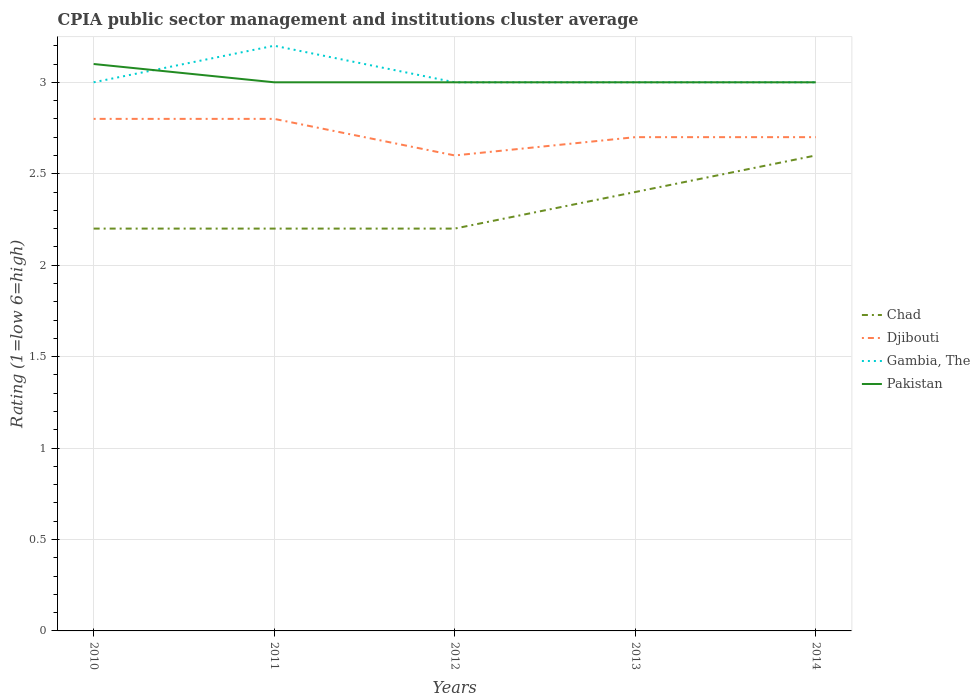Is the number of lines equal to the number of legend labels?
Make the answer very short. Yes. Across all years, what is the maximum CPIA rating in Chad?
Your answer should be very brief. 2.2. What is the difference between the highest and the second highest CPIA rating in Gambia, The?
Offer a terse response. 0.2. What is the difference between the highest and the lowest CPIA rating in Djibouti?
Your answer should be compact. 2. How many years are there in the graph?
Provide a short and direct response. 5. Are the values on the major ticks of Y-axis written in scientific E-notation?
Your response must be concise. No. Does the graph contain grids?
Your answer should be very brief. Yes. How many legend labels are there?
Give a very brief answer. 4. How are the legend labels stacked?
Offer a very short reply. Vertical. What is the title of the graph?
Offer a very short reply. CPIA public sector management and institutions cluster average. What is the label or title of the X-axis?
Provide a short and direct response. Years. What is the Rating (1=low 6=high) of Djibouti in 2010?
Provide a short and direct response. 2.8. What is the Rating (1=low 6=high) of Gambia, The in 2010?
Offer a very short reply. 3. What is the Rating (1=low 6=high) of Chad in 2011?
Offer a terse response. 2.2. What is the Rating (1=low 6=high) of Djibouti in 2011?
Make the answer very short. 2.8. What is the Rating (1=low 6=high) of Gambia, The in 2011?
Offer a terse response. 3.2. What is the Rating (1=low 6=high) of Pakistan in 2011?
Give a very brief answer. 3. What is the Rating (1=low 6=high) of Pakistan in 2012?
Offer a terse response. 3. What is the Rating (1=low 6=high) of Chad in 2013?
Provide a succinct answer. 2.4. What is the Rating (1=low 6=high) of Gambia, The in 2013?
Ensure brevity in your answer.  3. What is the Rating (1=low 6=high) of Pakistan in 2013?
Your answer should be compact. 3. What is the Rating (1=low 6=high) in Djibouti in 2014?
Your response must be concise. 2.7. What is the Rating (1=low 6=high) of Gambia, The in 2014?
Your response must be concise. 3. Across all years, what is the maximum Rating (1=low 6=high) of Chad?
Ensure brevity in your answer.  2.6. Across all years, what is the maximum Rating (1=low 6=high) of Pakistan?
Your answer should be very brief. 3.1. Across all years, what is the minimum Rating (1=low 6=high) in Chad?
Provide a succinct answer. 2.2. Across all years, what is the minimum Rating (1=low 6=high) of Djibouti?
Your response must be concise. 2.6. Across all years, what is the minimum Rating (1=low 6=high) in Gambia, The?
Offer a very short reply. 3. Across all years, what is the minimum Rating (1=low 6=high) of Pakistan?
Ensure brevity in your answer.  3. What is the total Rating (1=low 6=high) of Djibouti in the graph?
Keep it short and to the point. 13.6. What is the total Rating (1=low 6=high) of Pakistan in the graph?
Your response must be concise. 15.1. What is the difference between the Rating (1=low 6=high) of Djibouti in 2010 and that in 2011?
Keep it short and to the point. 0. What is the difference between the Rating (1=low 6=high) in Pakistan in 2010 and that in 2011?
Ensure brevity in your answer.  0.1. What is the difference between the Rating (1=low 6=high) of Gambia, The in 2010 and that in 2012?
Give a very brief answer. 0. What is the difference between the Rating (1=low 6=high) of Djibouti in 2010 and that in 2013?
Your answer should be compact. 0.1. What is the difference between the Rating (1=low 6=high) in Gambia, The in 2010 and that in 2013?
Provide a short and direct response. 0. What is the difference between the Rating (1=low 6=high) in Pakistan in 2010 and that in 2013?
Ensure brevity in your answer.  0.1. What is the difference between the Rating (1=low 6=high) in Djibouti in 2010 and that in 2014?
Your response must be concise. 0.1. What is the difference between the Rating (1=low 6=high) in Pakistan in 2010 and that in 2014?
Your answer should be very brief. 0.1. What is the difference between the Rating (1=low 6=high) in Chad in 2011 and that in 2013?
Ensure brevity in your answer.  -0.2. What is the difference between the Rating (1=low 6=high) of Djibouti in 2011 and that in 2013?
Give a very brief answer. 0.1. What is the difference between the Rating (1=low 6=high) in Pakistan in 2011 and that in 2013?
Ensure brevity in your answer.  0. What is the difference between the Rating (1=low 6=high) of Djibouti in 2011 and that in 2014?
Offer a terse response. 0.1. What is the difference between the Rating (1=low 6=high) of Gambia, The in 2011 and that in 2014?
Give a very brief answer. 0.2. What is the difference between the Rating (1=low 6=high) in Djibouti in 2012 and that in 2013?
Give a very brief answer. -0.1. What is the difference between the Rating (1=low 6=high) of Pakistan in 2012 and that in 2013?
Make the answer very short. 0. What is the difference between the Rating (1=low 6=high) in Chad in 2012 and that in 2014?
Make the answer very short. -0.4. What is the difference between the Rating (1=low 6=high) in Djibouti in 2012 and that in 2014?
Your response must be concise. -0.1. What is the difference between the Rating (1=low 6=high) in Pakistan in 2012 and that in 2014?
Make the answer very short. 0. What is the difference between the Rating (1=low 6=high) of Djibouti in 2013 and that in 2014?
Provide a short and direct response. 0. What is the difference between the Rating (1=low 6=high) in Gambia, The in 2013 and that in 2014?
Keep it short and to the point. 0. What is the difference between the Rating (1=low 6=high) of Chad in 2010 and the Rating (1=low 6=high) of Gambia, The in 2011?
Offer a very short reply. -1. What is the difference between the Rating (1=low 6=high) of Chad in 2010 and the Rating (1=low 6=high) of Pakistan in 2011?
Provide a short and direct response. -0.8. What is the difference between the Rating (1=low 6=high) in Gambia, The in 2010 and the Rating (1=low 6=high) in Pakistan in 2011?
Keep it short and to the point. 0. What is the difference between the Rating (1=low 6=high) in Djibouti in 2010 and the Rating (1=low 6=high) in Gambia, The in 2012?
Offer a terse response. -0.2. What is the difference between the Rating (1=low 6=high) of Chad in 2010 and the Rating (1=low 6=high) of Gambia, The in 2013?
Keep it short and to the point. -0.8. What is the difference between the Rating (1=low 6=high) in Djibouti in 2010 and the Rating (1=low 6=high) in Gambia, The in 2013?
Provide a succinct answer. -0.2. What is the difference between the Rating (1=low 6=high) of Gambia, The in 2010 and the Rating (1=low 6=high) of Pakistan in 2013?
Offer a very short reply. 0. What is the difference between the Rating (1=low 6=high) in Chad in 2010 and the Rating (1=low 6=high) in Gambia, The in 2014?
Offer a terse response. -0.8. What is the difference between the Rating (1=low 6=high) of Chad in 2010 and the Rating (1=low 6=high) of Pakistan in 2014?
Your answer should be very brief. -0.8. What is the difference between the Rating (1=low 6=high) of Djibouti in 2010 and the Rating (1=low 6=high) of Gambia, The in 2014?
Offer a terse response. -0.2. What is the difference between the Rating (1=low 6=high) in Djibouti in 2010 and the Rating (1=low 6=high) in Pakistan in 2014?
Give a very brief answer. -0.2. What is the difference between the Rating (1=low 6=high) in Gambia, The in 2010 and the Rating (1=low 6=high) in Pakistan in 2014?
Provide a succinct answer. 0. What is the difference between the Rating (1=low 6=high) in Chad in 2011 and the Rating (1=low 6=high) in Djibouti in 2012?
Keep it short and to the point. -0.4. What is the difference between the Rating (1=low 6=high) of Chad in 2011 and the Rating (1=low 6=high) of Pakistan in 2012?
Offer a terse response. -0.8. What is the difference between the Rating (1=low 6=high) of Djibouti in 2011 and the Rating (1=low 6=high) of Gambia, The in 2012?
Provide a short and direct response. -0.2. What is the difference between the Rating (1=low 6=high) of Gambia, The in 2011 and the Rating (1=low 6=high) of Pakistan in 2012?
Your answer should be very brief. 0.2. What is the difference between the Rating (1=low 6=high) in Chad in 2011 and the Rating (1=low 6=high) in Gambia, The in 2013?
Your response must be concise. -0.8. What is the difference between the Rating (1=low 6=high) of Chad in 2011 and the Rating (1=low 6=high) of Pakistan in 2013?
Provide a succinct answer. -0.8. What is the difference between the Rating (1=low 6=high) in Chad in 2011 and the Rating (1=low 6=high) in Djibouti in 2014?
Provide a short and direct response. -0.5. What is the difference between the Rating (1=low 6=high) of Chad in 2011 and the Rating (1=low 6=high) of Gambia, The in 2014?
Offer a terse response. -0.8. What is the difference between the Rating (1=low 6=high) in Chad in 2011 and the Rating (1=low 6=high) in Pakistan in 2014?
Give a very brief answer. -0.8. What is the difference between the Rating (1=low 6=high) of Djibouti in 2011 and the Rating (1=low 6=high) of Gambia, The in 2014?
Offer a very short reply. -0.2. What is the difference between the Rating (1=low 6=high) in Gambia, The in 2011 and the Rating (1=low 6=high) in Pakistan in 2014?
Your answer should be very brief. 0.2. What is the difference between the Rating (1=low 6=high) of Chad in 2012 and the Rating (1=low 6=high) of Gambia, The in 2013?
Your answer should be very brief. -0.8. What is the difference between the Rating (1=low 6=high) in Chad in 2012 and the Rating (1=low 6=high) in Pakistan in 2013?
Make the answer very short. -0.8. What is the difference between the Rating (1=low 6=high) of Djibouti in 2012 and the Rating (1=low 6=high) of Gambia, The in 2013?
Your answer should be very brief. -0.4. What is the difference between the Rating (1=low 6=high) in Djibouti in 2012 and the Rating (1=low 6=high) in Pakistan in 2013?
Make the answer very short. -0.4. What is the difference between the Rating (1=low 6=high) in Chad in 2012 and the Rating (1=low 6=high) in Djibouti in 2014?
Keep it short and to the point. -0.5. What is the difference between the Rating (1=low 6=high) of Gambia, The in 2012 and the Rating (1=low 6=high) of Pakistan in 2014?
Your answer should be very brief. 0. What is the difference between the Rating (1=low 6=high) in Chad in 2013 and the Rating (1=low 6=high) in Djibouti in 2014?
Your response must be concise. -0.3. What is the difference between the Rating (1=low 6=high) in Chad in 2013 and the Rating (1=low 6=high) in Gambia, The in 2014?
Give a very brief answer. -0.6. What is the difference between the Rating (1=low 6=high) of Chad in 2013 and the Rating (1=low 6=high) of Pakistan in 2014?
Offer a very short reply. -0.6. What is the difference between the Rating (1=low 6=high) in Djibouti in 2013 and the Rating (1=low 6=high) in Gambia, The in 2014?
Keep it short and to the point. -0.3. What is the difference between the Rating (1=low 6=high) of Djibouti in 2013 and the Rating (1=low 6=high) of Pakistan in 2014?
Provide a succinct answer. -0.3. What is the difference between the Rating (1=low 6=high) of Gambia, The in 2013 and the Rating (1=low 6=high) of Pakistan in 2014?
Your response must be concise. 0. What is the average Rating (1=low 6=high) in Chad per year?
Give a very brief answer. 2.32. What is the average Rating (1=low 6=high) of Djibouti per year?
Your answer should be very brief. 2.72. What is the average Rating (1=low 6=high) in Gambia, The per year?
Your response must be concise. 3.04. What is the average Rating (1=low 6=high) in Pakistan per year?
Keep it short and to the point. 3.02. In the year 2010, what is the difference between the Rating (1=low 6=high) in Chad and Rating (1=low 6=high) in Djibouti?
Offer a terse response. -0.6. In the year 2010, what is the difference between the Rating (1=low 6=high) in Gambia, The and Rating (1=low 6=high) in Pakistan?
Your response must be concise. -0.1. In the year 2011, what is the difference between the Rating (1=low 6=high) of Chad and Rating (1=low 6=high) of Pakistan?
Provide a short and direct response. -0.8. In the year 2011, what is the difference between the Rating (1=low 6=high) in Djibouti and Rating (1=low 6=high) in Gambia, The?
Give a very brief answer. -0.4. In the year 2011, what is the difference between the Rating (1=low 6=high) in Gambia, The and Rating (1=low 6=high) in Pakistan?
Ensure brevity in your answer.  0.2. In the year 2012, what is the difference between the Rating (1=low 6=high) in Chad and Rating (1=low 6=high) in Gambia, The?
Ensure brevity in your answer.  -0.8. In the year 2012, what is the difference between the Rating (1=low 6=high) in Djibouti and Rating (1=low 6=high) in Gambia, The?
Your answer should be compact. -0.4. In the year 2012, what is the difference between the Rating (1=low 6=high) of Djibouti and Rating (1=low 6=high) of Pakistan?
Offer a very short reply. -0.4. In the year 2012, what is the difference between the Rating (1=low 6=high) of Gambia, The and Rating (1=low 6=high) of Pakistan?
Provide a succinct answer. 0. In the year 2013, what is the difference between the Rating (1=low 6=high) of Chad and Rating (1=low 6=high) of Djibouti?
Offer a very short reply. -0.3. In the year 2013, what is the difference between the Rating (1=low 6=high) of Chad and Rating (1=low 6=high) of Gambia, The?
Your answer should be compact. -0.6. In the year 2014, what is the difference between the Rating (1=low 6=high) in Djibouti and Rating (1=low 6=high) in Gambia, The?
Your response must be concise. -0.3. In the year 2014, what is the difference between the Rating (1=low 6=high) of Djibouti and Rating (1=low 6=high) of Pakistan?
Offer a very short reply. -0.3. In the year 2014, what is the difference between the Rating (1=low 6=high) of Gambia, The and Rating (1=low 6=high) of Pakistan?
Offer a terse response. 0. What is the ratio of the Rating (1=low 6=high) in Chad in 2010 to that in 2011?
Provide a succinct answer. 1. What is the ratio of the Rating (1=low 6=high) in Gambia, The in 2010 to that in 2011?
Your answer should be compact. 0.94. What is the ratio of the Rating (1=low 6=high) of Pakistan in 2010 to that in 2011?
Offer a terse response. 1.03. What is the ratio of the Rating (1=low 6=high) in Chad in 2010 to that in 2012?
Your response must be concise. 1. What is the ratio of the Rating (1=low 6=high) of Djibouti in 2010 to that in 2012?
Your answer should be compact. 1.08. What is the ratio of the Rating (1=low 6=high) of Gambia, The in 2010 to that in 2012?
Keep it short and to the point. 1. What is the ratio of the Rating (1=low 6=high) of Pakistan in 2010 to that in 2012?
Ensure brevity in your answer.  1.03. What is the ratio of the Rating (1=low 6=high) in Chad in 2010 to that in 2013?
Keep it short and to the point. 0.92. What is the ratio of the Rating (1=low 6=high) of Chad in 2010 to that in 2014?
Provide a short and direct response. 0.85. What is the ratio of the Rating (1=low 6=high) of Gambia, The in 2010 to that in 2014?
Your answer should be very brief. 1. What is the ratio of the Rating (1=low 6=high) in Pakistan in 2010 to that in 2014?
Your response must be concise. 1.03. What is the ratio of the Rating (1=low 6=high) of Gambia, The in 2011 to that in 2012?
Give a very brief answer. 1.07. What is the ratio of the Rating (1=low 6=high) in Chad in 2011 to that in 2013?
Keep it short and to the point. 0.92. What is the ratio of the Rating (1=low 6=high) in Gambia, The in 2011 to that in 2013?
Offer a terse response. 1.07. What is the ratio of the Rating (1=low 6=high) in Chad in 2011 to that in 2014?
Make the answer very short. 0.85. What is the ratio of the Rating (1=low 6=high) of Gambia, The in 2011 to that in 2014?
Provide a short and direct response. 1.07. What is the ratio of the Rating (1=low 6=high) of Chad in 2012 to that in 2013?
Offer a terse response. 0.92. What is the ratio of the Rating (1=low 6=high) in Djibouti in 2012 to that in 2013?
Offer a terse response. 0.96. What is the ratio of the Rating (1=low 6=high) of Chad in 2012 to that in 2014?
Offer a very short reply. 0.85. What is the ratio of the Rating (1=low 6=high) in Pakistan in 2012 to that in 2014?
Give a very brief answer. 1. What is the ratio of the Rating (1=low 6=high) of Chad in 2013 to that in 2014?
Keep it short and to the point. 0.92. What is the ratio of the Rating (1=low 6=high) in Gambia, The in 2013 to that in 2014?
Offer a terse response. 1. What is the difference between the highest and the second highest Rating (1=low 6=high) in Chad?
Provide a succinct answer. 0.2. What is the difference between the highest and the second highest Rating (1=low 6=high) of Pakistan?
Your answer should be very brief. 0.1. What is the difference between the highest and the lowest Rating (1=low 6=high) in Djibouti?
Ensure brevity in your answer.  0.2. What is the difference between the highest and the lowest Rating (1=low 6=high) of Gambia, The?
Give a very brief answer. 0.2. What is the difference between the highest and the lowest Rating (1=low 6=high) of Pakistan?
Provide a succinct answer. 0.1. 